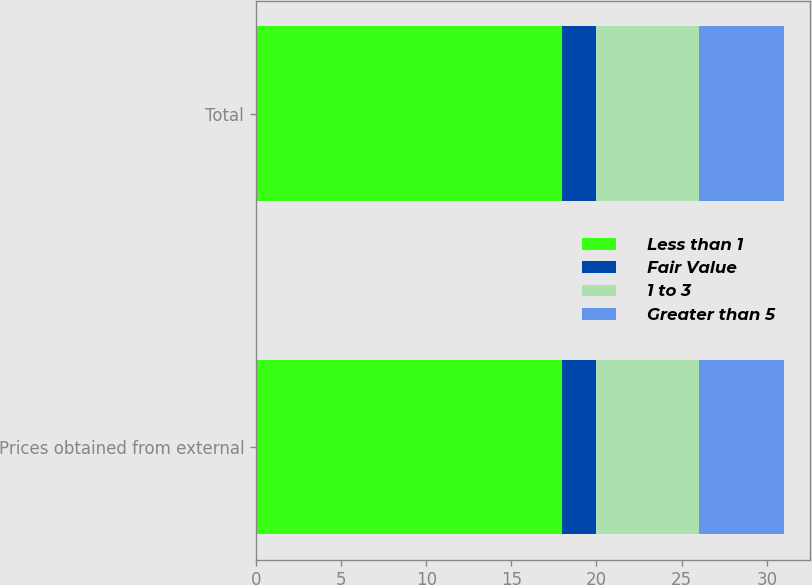<chart> <loc_0><loc_0><loc_500><loc_500><stacked_bar_chart><ecel><fcel>Prices obtained from external<fcel>Total<nl><fcel>Less than 1<fcel>18<fcel>18<nl><fcel>Fair Value<fcel>2<fcel>2<nl><fcel>1 to 3<fcel>6<fcel>6<nl><fcel>Greater than 5<fcel>5<fcel>5<nl></chart> 